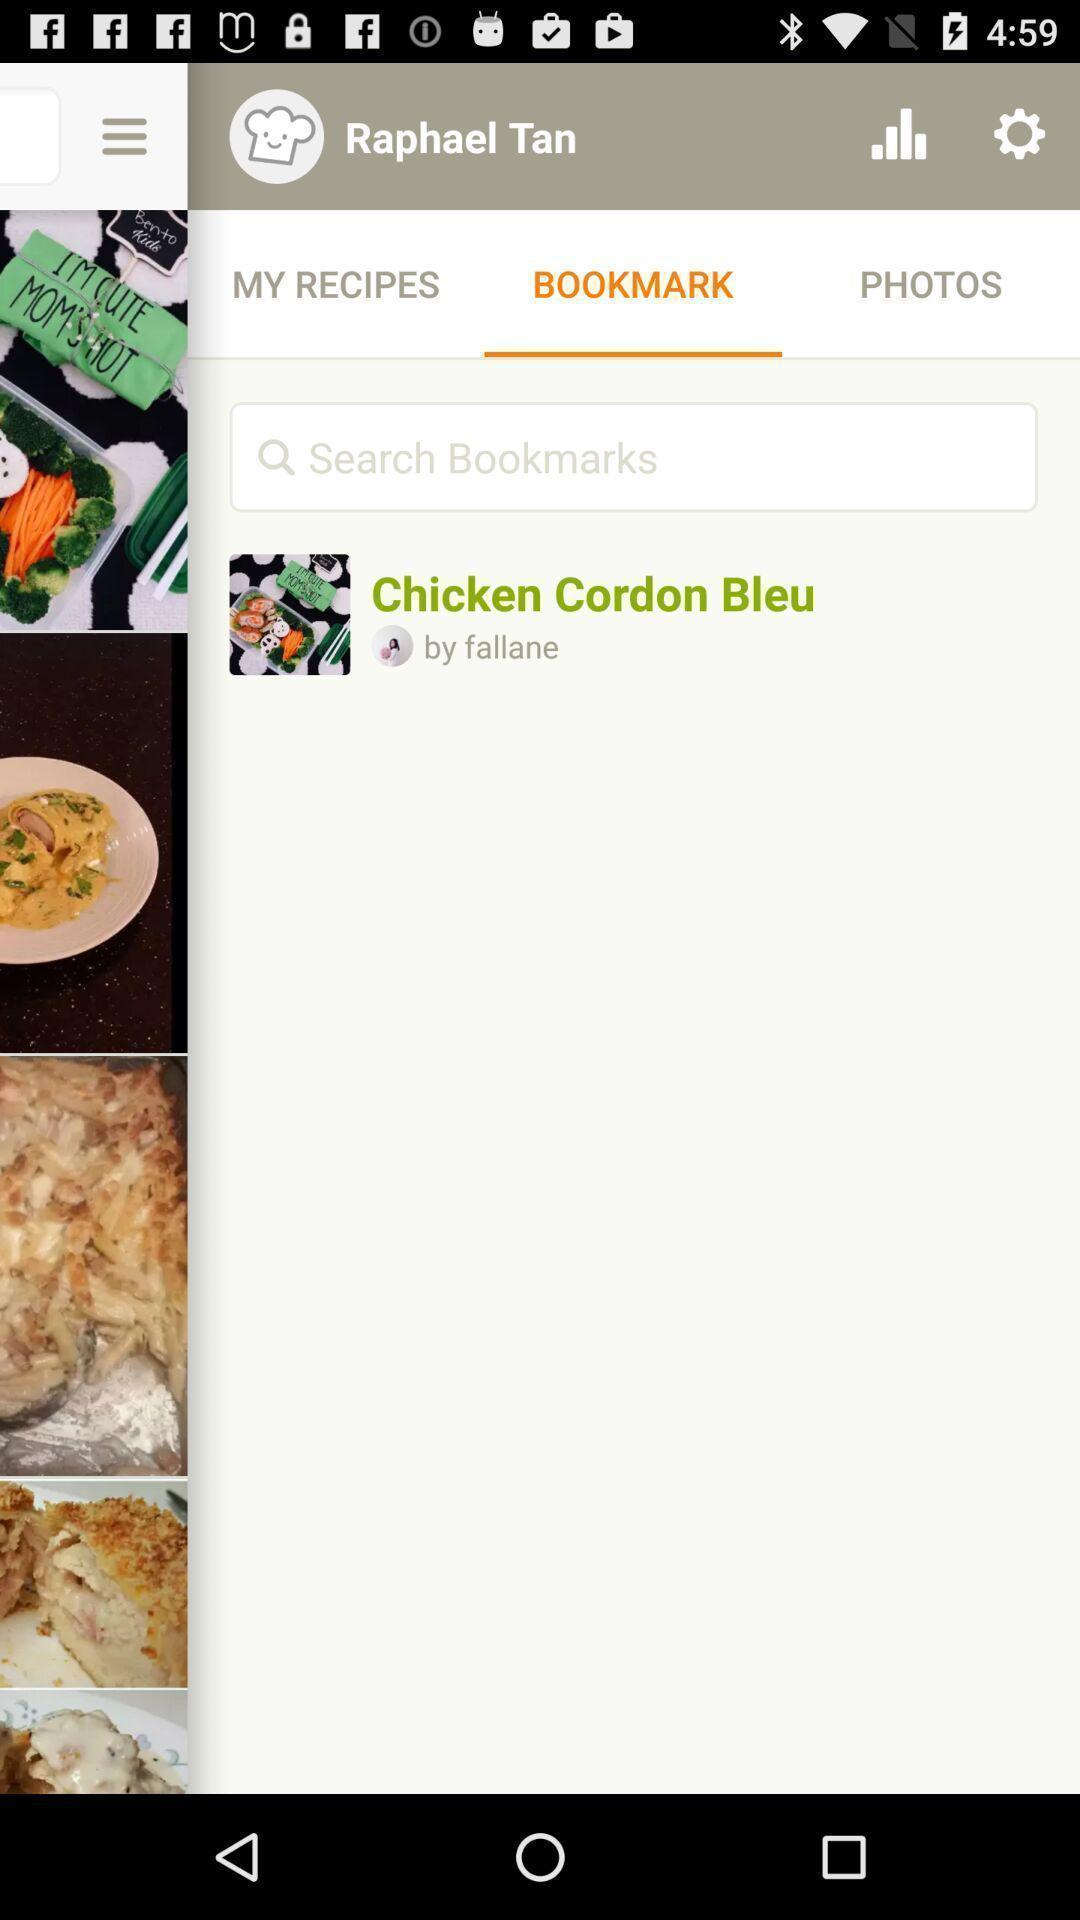What is the overall content of this screenshot? Search bar to search bookmarks in an cooking application. 